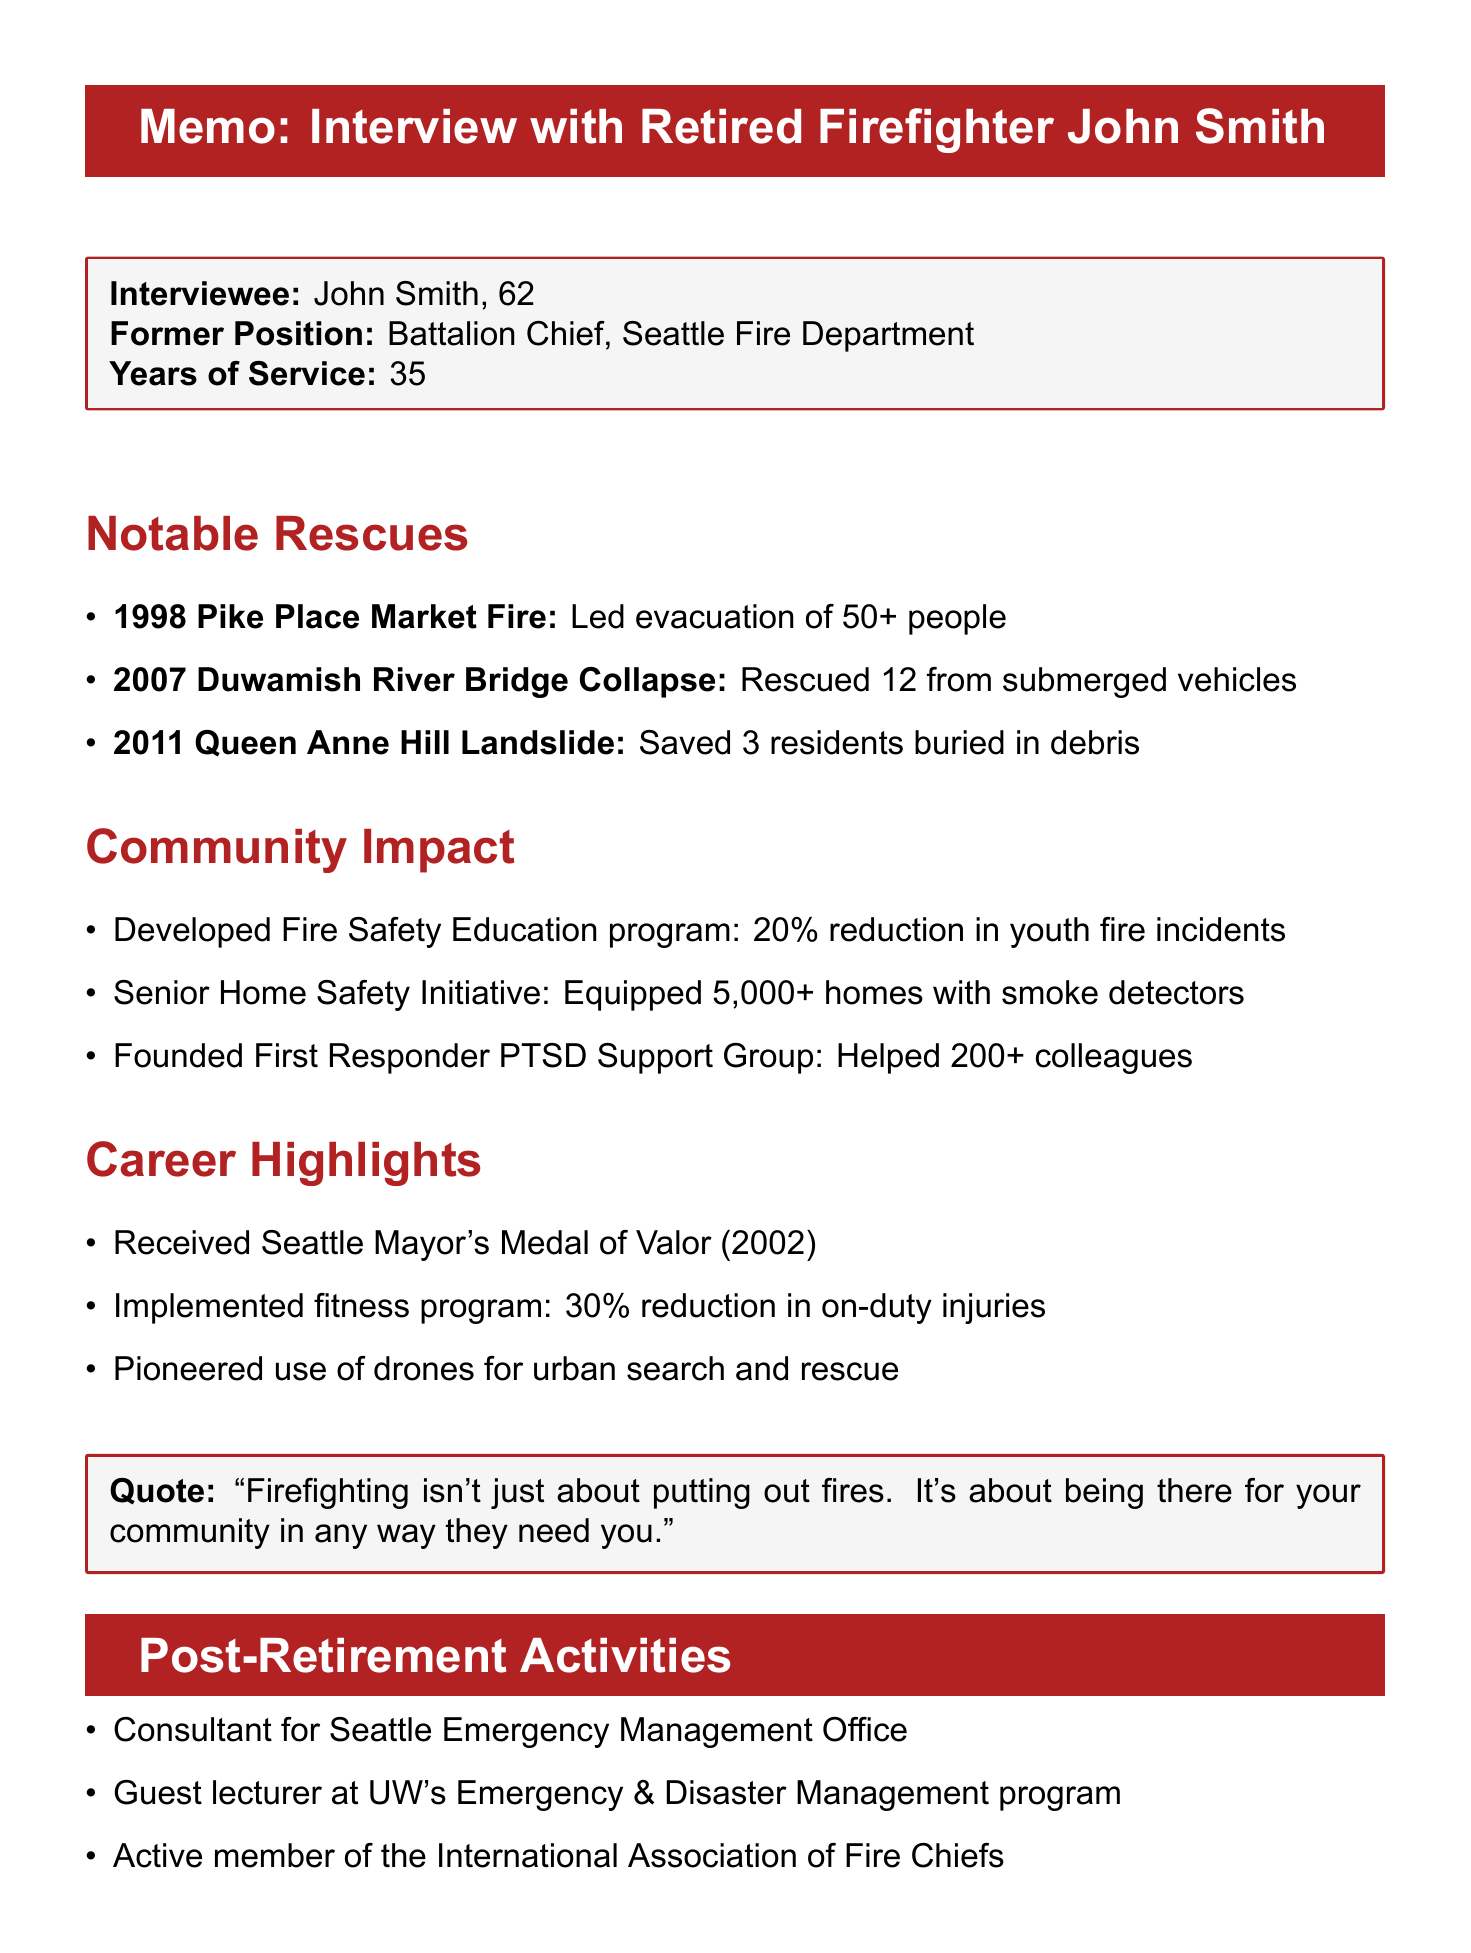What was John Smith's age during the interview? The document states that John Smith is 62 years old.
Answer: 62 What position did John Smith hold in the Seattle Fire Department? The document specifies that John Smith was a Battalion Chief.
Answer: Battalion Chief In which year did the Pike Place Market fire occur? The document lists the Pike Place Market fire as happening in 1998.
Answer: 1998 How many motorists were rescued during the Duwamish River Bridge collapse? The document mentions that 12 motorists were rescued.
Answer: 12 What percentage reduction in youth-related fire incidents was achieved through the Fire Safety Education program? The document states there was a 20% reduction.
Answer: 20% What impact did the First Responder PTSD Support Group have on department turnover? The document indicates that it reduced turnover by 15%.
Answer: 15% Which award did John Smith receive in 2002? The document mentions that he received the Seattle Mayor's Medal of Valor.
Answer: Seattle Mayor's Medal of Valor Which program developed by John Smith reached over 10,000 students annually? The document states that the Fire Safety Education program developed this reach.
Answer: Fire Safety Education in Schools What type of program did John Smith implement to reduce on-duty injuries? The document notes that a physical fitness program was implemented.
Answer: Physical fitness program 